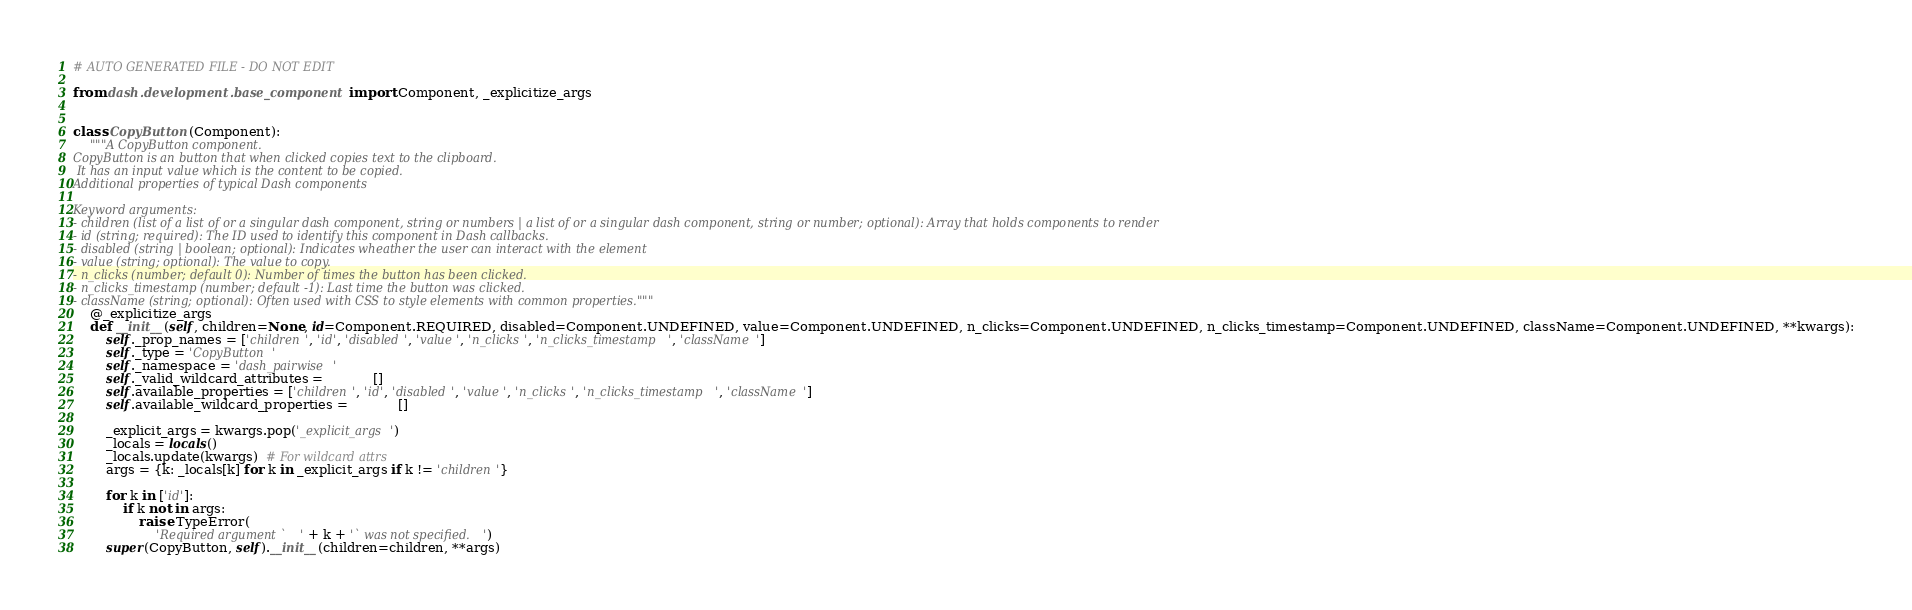Convert code to text. <code><loc_0><loc_0><loc_500><loc_500><_Python_># AUTO GENERATED FILE - DO NOT EDIT

from dash.development.base_component import Component, _explicitize_args


class CopyButton(Component):
    """A CopyButton component.
CopyButton is an button that when clicked copies text to the clipboard.
 It has an input value which is the content to be copied.
Additional properties of typical Dash components

Keyword arguments:
- children (list of a list of or a singular dash component, string or numbers | a list of or a singular dash component, string or number; optional): Array that holds components to render
- id (string; required): The ID used to identify this component in Dash callbacks.
- disabled (string | boolean; optional): Indicates wheather the user can interact with the element
- value (string; optional): The value to copy.
- n_clicks (number; default 0): Number of times the button has been clicked.
- n_clicks_timestamp (number; default -1): Last time the button was clicked.
- className (string; optional): Often used with CSS to style elements with common properties."""
    @_explicitize_args
    def __init__(self, children=None, id=Component.REQUIRED, disabled=Component.UNDEFINED, value=Component.UNDEFINED, n_clicks=Component.UNDEFINED, n_clicks_timestamp=Component.UNDEFINED, className=Component.UNDEFINED, **kwargs):
        self._prop_names = ['children', 'id', 'disabled', 'value', 'n_clicks', 'n_clicks_timestamp', 'className']
        self._type = 'CopyButton'
        self._namespace = 'dash_pairwise'
        self._valid_wildcard_attributes =            []
        self.available_properties = ['children', 'id', 'disabled', 'value', 'n_clicks', 'n_clicks_timestamp', 'className']
        self.available_wildcard_properties =            []

        _explicit_args = kwargs.pop('_explicit_args')
        _locals = locals()
        _locals.update(kwargs)  # For wildcard attrs
        args = {k: _locals[k] for k in _explicit_args if k != 'children'}

        for k in ['id']:
            if k not in args:
                raise TypeError(
                    'Required argument `' + k + '` was not specified.')
        super(CopyButton, self).__init__(children=children, **args)
</code> 